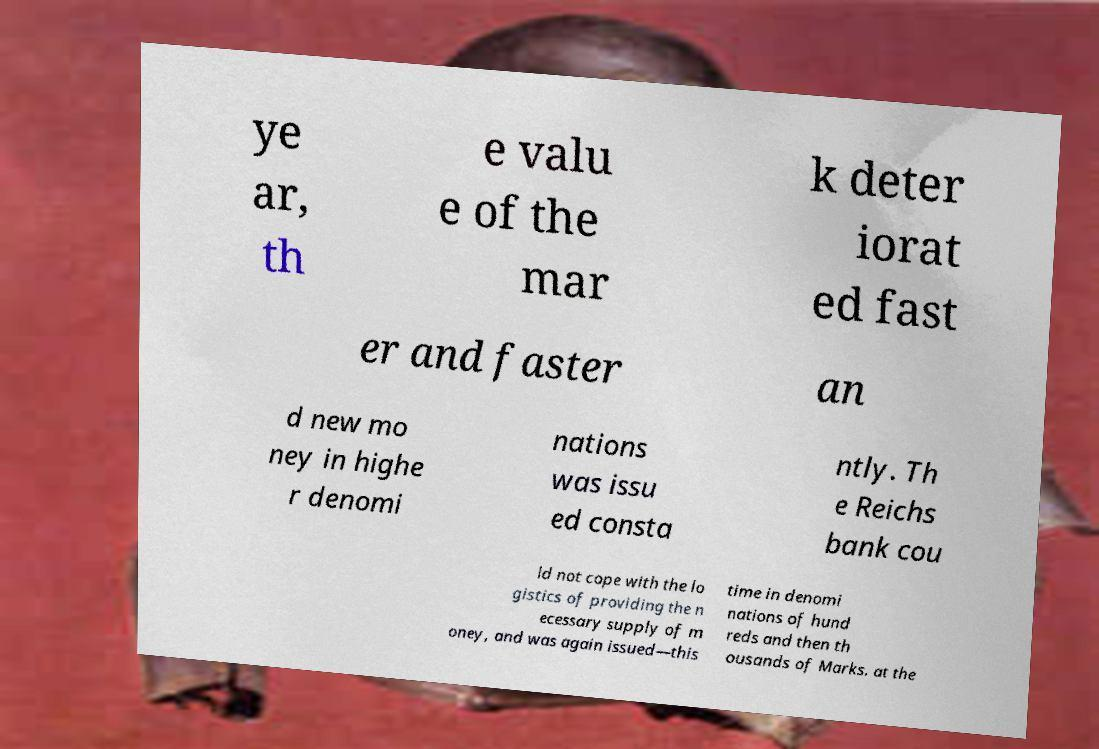Can you read and provide the text displayed in the image?This photo seems to have some interesting text. Can you extract and type it out for me? ye ar, th e valu e of the mar k deter iorat ed fast er and faster an d new mo ney in highe r denomi nations was issu ed consta ntly. Th e Reichs bank cou ld not cope with the lo gistics of providing the n ecessary supply of m oney, and was again issued—this time in denomi nations of hund reds and then th ousands of Marks. at the 